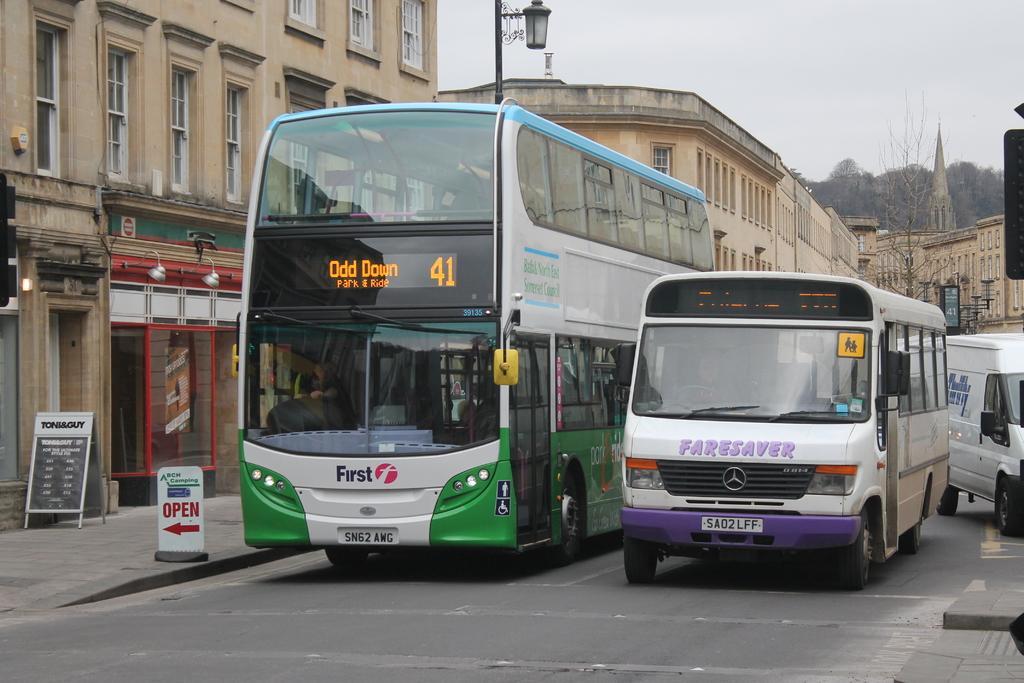Please provide a concise description of this image. In this picture there are vehicles in the center of the image and there are buildings, trees, poles, and posters in the background area of the image. 